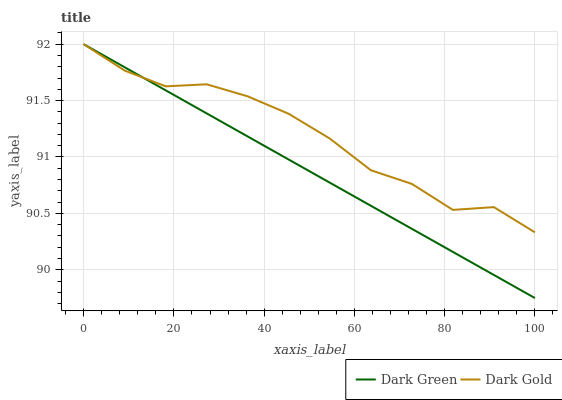Does Dark Green have the minimum area under the curve?
Answer yes or no. Yes. Does Dark Gold have the maximum area under the curve?
Answer yes or no. Yes. Does Dark Green have the maximum area under the curve?
Answer yes or no. No. Is Dark Green the smoothest?
Answer yes or no. Yes. Is Dark Gold the roughest?
Answer yes or no. Yes. Is Dark Green the roughest?
Answer yes or no. No. Does Dark Green have the highest value?
Answer yes or no. Yes. Does Dark Gold intersect Dark Green?
Answer yes or no. Yes. Is Dark Gold less than Dark Green?
Answer yes or no. No. Is Dark Gold greater than Dark Green?
Answer yes or no. No. 